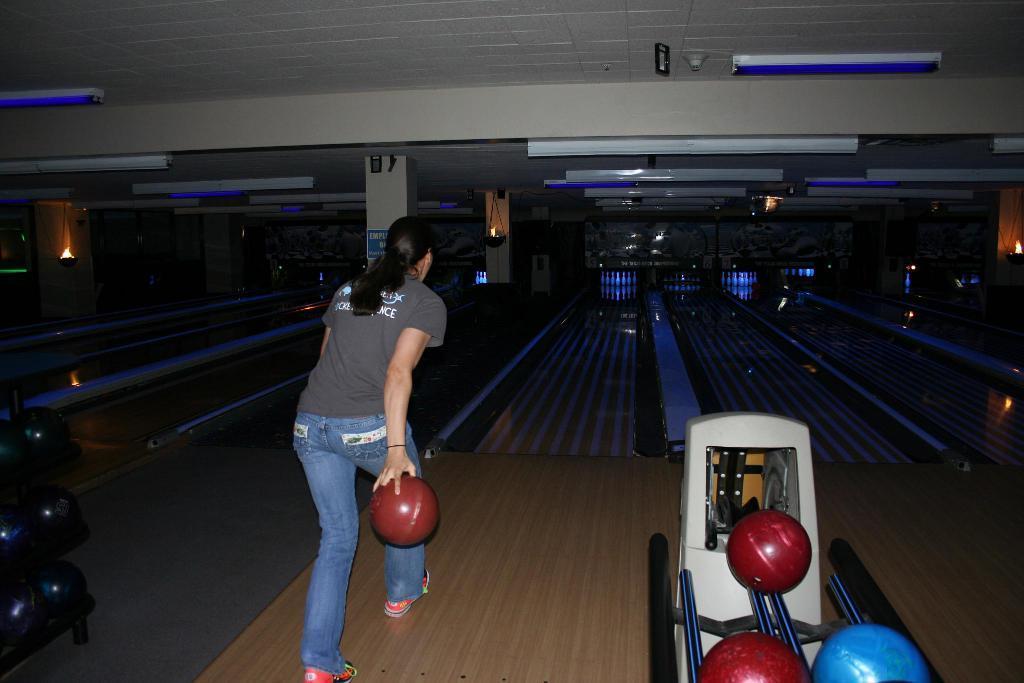Please provide a concise description of this image. In this image I can see the person wearing the grey and blue color dress and she is holding the red color ball. To the right there are red and blue color balls on the stand. In the back I can see the bowling stadium and I can see the bowling pins in the back. I can see some lights and the ceiling. 